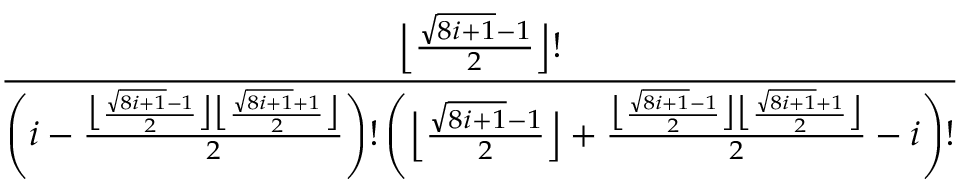Convert formula to latex. <formula><loc_0><loc_0><loc_500><loc_500>\frac { \left \lfloor \frac { \sqrt { 8 i + 1 } - 1 } { 2 } \right \rfloor ! } { \left ( i - \frac { \left \lfloor \frac { \sqrt { 8 i + 1 } - 1 } { 2 } \right \rfloor \left \lfloor \frac { \sqrt { 8 i + 1 } + 1 } { 2 } \right \rfloor } { 2 } \right ) ! \left ( \left \lfloor \frac { \sqrt { 8 i + 1 } - 1 } { 2 } \right \rfloor + \frac { \left \lfloor \frac { \sqrt { 8 i + 1 } - 1 } { 2 } \right \rfloor \left \lfloor \frac { \sqrt { 8 i + 1 } + 1 } { 2 } \right \rfloor } { 2 } - i \right ) ! }</formula> 